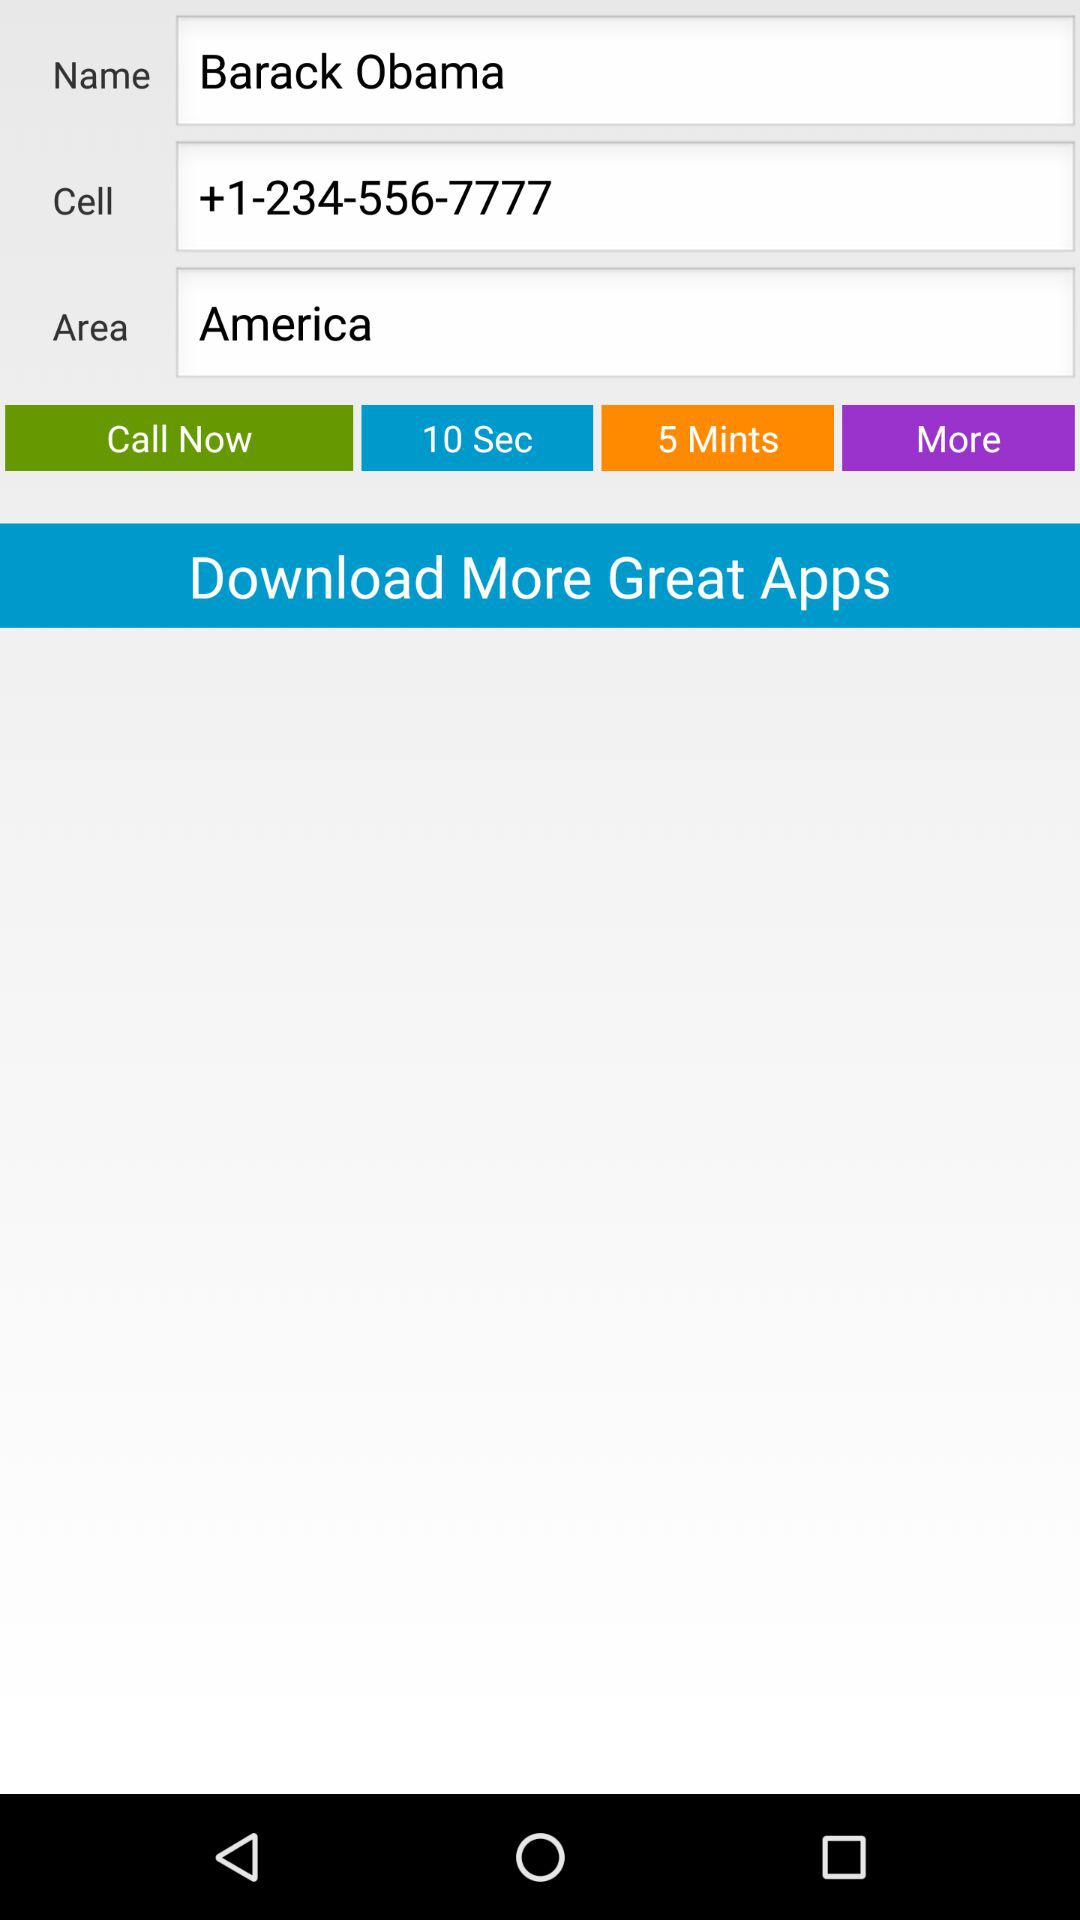What is the cell number? The cell number is +1-234-556-7777. 